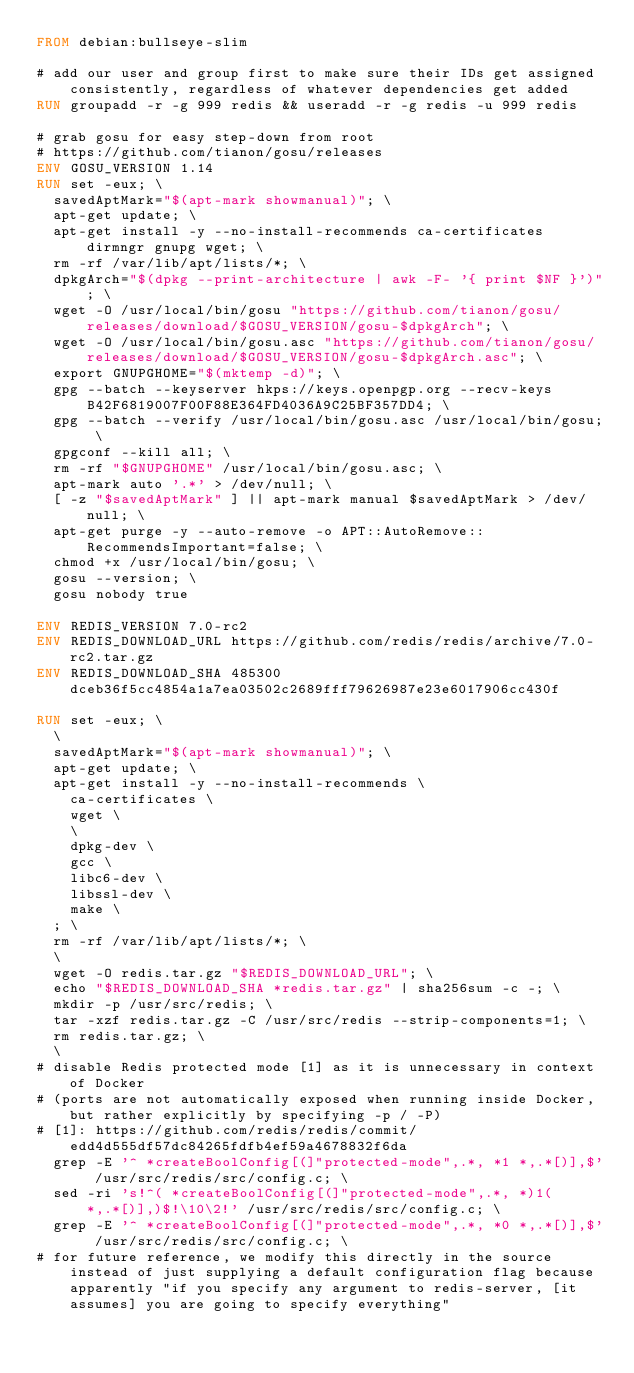<code> <loc_0><loc_0><loc_500><loc_500><_Dockerfile_>FROM debian:bullseye-slim

# add our user and group first to make sure their IDs get assigned consistently, regardless of whatever dependencies get added
RUN groupadd -r -g 999 redis && useradd -r -g redis -u 999 redis

# grab gosu for easy step-down from root
# https://github.com/tianon/gosu/releases
ENV GOSU_VERSION 1.14
RUN set -eux; \
	savedAptMark="$(apt-mark showmanual)"; \
	apt-get update; \
	apt-get install -y --no-install-recommends ca-certificates dirmngr gnupg wget; \
	rm -rf /var/lib/apt/lists/*; \
	dpkgArch="$(dpkg --print-architecture | awk -F- '{ print $NF }')"; \
	wget -O /usr/local/bin/gosu "https://github.com/tianon/gosu/releases/download/$GOSU_VERSION/gosu-$dpkgArch"; \
	wget -O /usr/local/bin/gosu.asc "https://github.com/tianon/gosu/releases/download/$GOSU_VERSION/gosu-$dpkgArch.asc"; \
	export GNUPGHOME="$(mktemp -d)"; \
	gpg --batch --keyserver hkps://keys.openpgp.org --recv-keys B42F6819007F00F88E364FD4036A9C25BF357DD4; \
	gpg --batch --verify /usr/local/bin/gosu.asc /usr/local/bin/gosu; \
	gpgconf --kill all; \
	rm -rf "$GNUPGHOME" /usr/local/bin/gosu.asc; \
	apt-mark auto '.*' > /dev/null; \
	[ -z "$savedAptMark" ] || apt-mark manual $savedAptMark > /dev/null; \
	apt-get purge -y --auto-remove -o APT::AutoRemove::RecommendsImportant=false; \
	chmod +x /usr/local/bin/gosu; \
	gosu --version; \
	gosu nobody true

ENV REDIS_VERSION 7.0-rc2
ENV REDIS_DOWNLOAD_URL https://github.com/redis/redis/archive/7.0-rc2.tar.gz
ENV REDIS_DOWNLOAD_SHA 485300dceb36f5cc4854a1a7ea03502c2689fff79626987e23e6017906cc430f

RUN set -eux; \
	\
	savedAptMark="$(apt-mark showmanual)"; \
	apt-get update; \
	apt-get install -y --no-install-recommends \
		ca-certificates \
		wget \
		\
		dpkg-dev \
		gcc \
		libc6-dev \
		libssl-dev \
		make \
	; \
	rm -rf /var/lib/apt/lists/*; \
	\
	wget -O redis.tar.gz "$REDIS_DOWNLOAD_URL"; \
	echo "$REDIS_DOWNLOAD_SHA *redis.tar.gz" | sha256sum -c -; \
	mkdir -p /usr/src/redis; \
	tar -xzf redis.tar.gz -C /usr/src/redis --strip-components=1; \
	rm redis.tar.gz; \
	\
# disable Redis protected mode [1] as it is unnecessary in context of Docker
# (ports are not automatically exposed when running inside Docker, but rather explicitly by specifying -p / -P)
# [1]: https://github.com/redis/redis/commit/edd4d555df57dc84265fdfb4ef59a4678832f6da
	grep -E '^ *createBoolConfig[(]"protected-mode",.*, *1 *,.*[)],$' /usr/src/redis/src/config.c; \
	sed -ri 's!^( *createBoolConfig[(]"protected-mode",.*, *)1( *,.*[)],)$!\10\2!' /usr/src/redis/src/config.c; \
	grep -E '^ *createBoolConfig[(]"protected-mode",.*, *0 *,.*[)],$' /usr/src/redis/src/config.c; \
# for future reference, we modify this directly in the source instead of just supplying a default configuration flag because apparently "if you specify any argument to redis-server, [it assumes] you are going to specify everything"</code> 